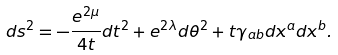<formula> <loc_0><loc_0><loc_500><loc_500>d s ^ { 2 } = - \frac { e ^ { 2 \mu } } { 4 t } d t ^ { 2 } + e ^ { 2 \lambda } d \theta ^ { 2 } + t \gamma _ { a b } d x ^ { a } d x ^ { b } .</formula> 